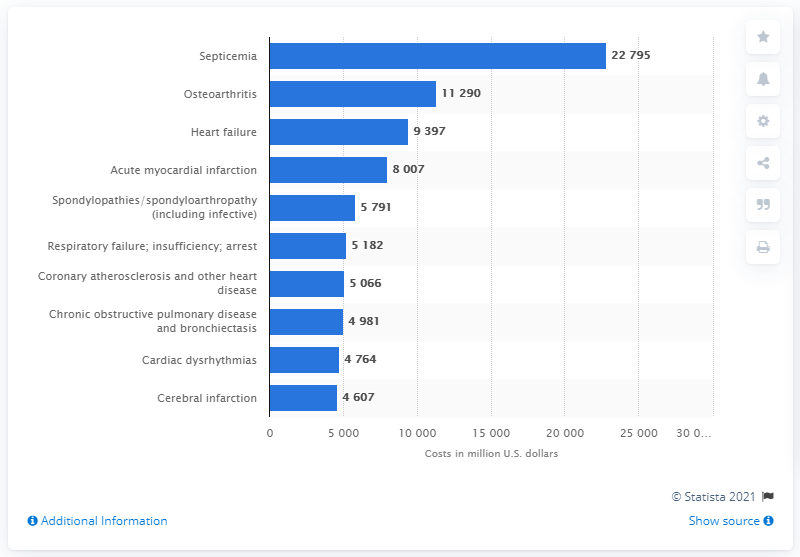Highlight a few significant elements in this photo. In 2017, the amount of money spent on heart failure was 9,397. 